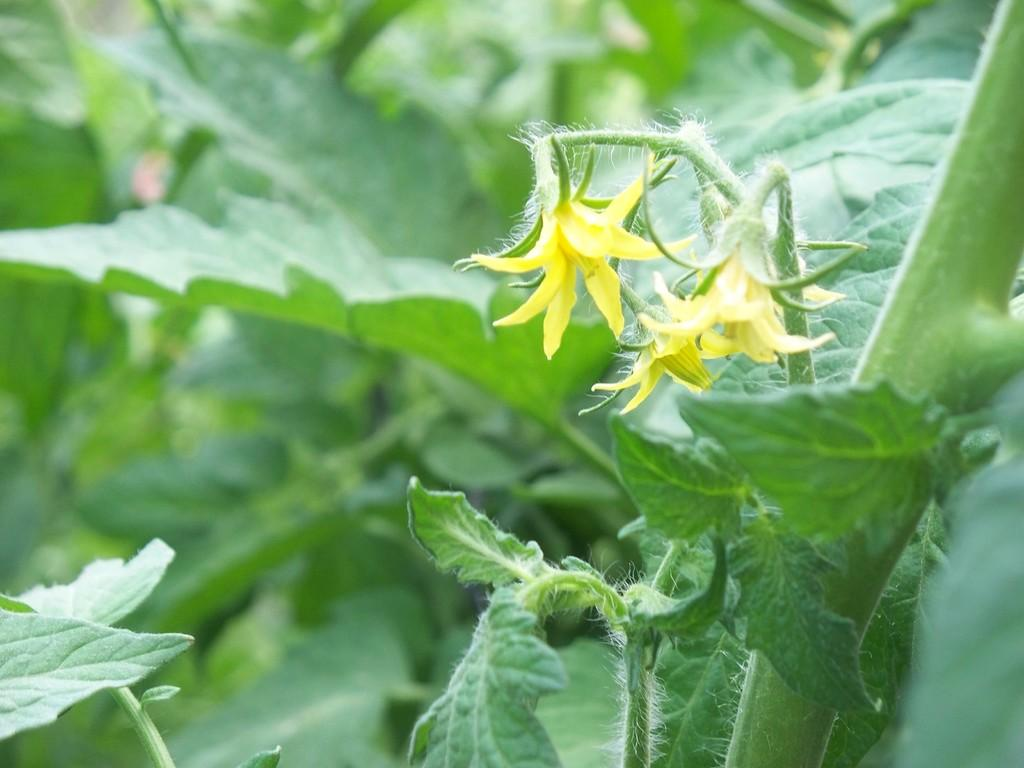What type of flowers can be seen in the image? There are yellow flowers in the image. What else is present in the image besides the flowers? There are plants in the image. What part of the plants is visible at the bottom of the image? Leaves are visible at the bottom of the image. How does the calculator start in the image? There is no calculator present in the image. 